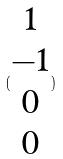Convert formula to latex. <formula><loc_0><loc_0><loc_500><loc_500>( \begin{matrix} 1 \\ - 1 \\ 0 \\ 0 \end{matrix} )</formula> 